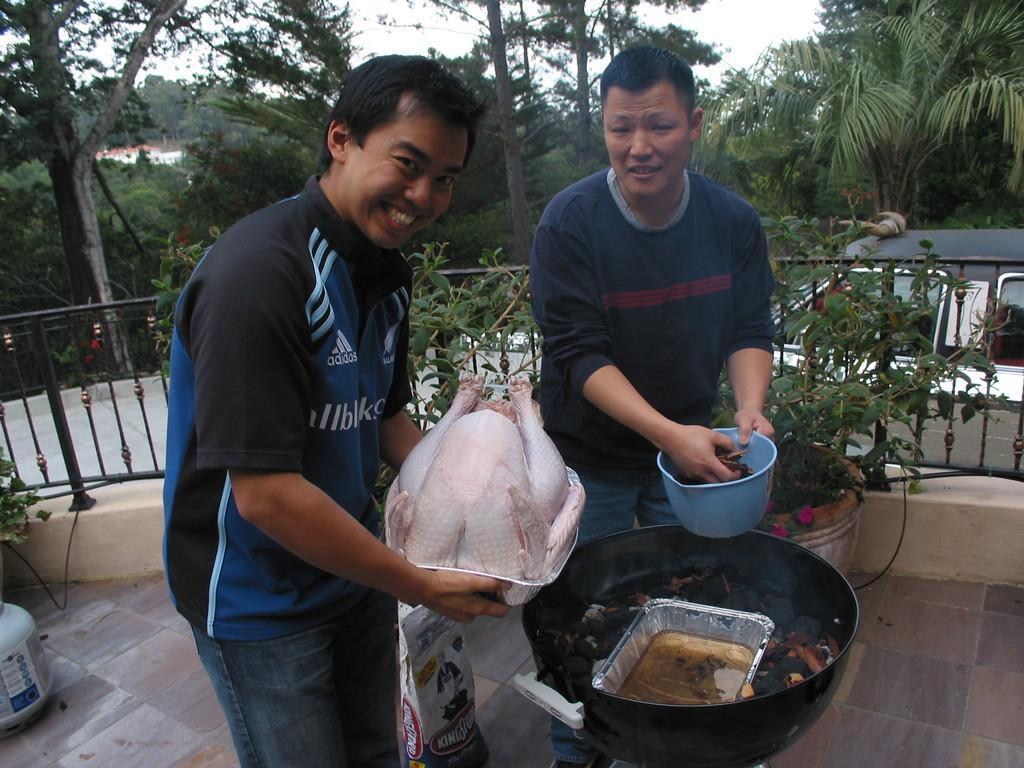Please provide a concise description of this image. In this picture there is a man on the left side of the image, by holding a peeled chicken in his hands and there is another man in the center of the image, by holding a bowl in his hands and there is a wok at the bottom side of the image, there is a boundary behind them and there are trees and a car in the background area of the image. 